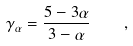<formula> <loc_0><loc_0><loc_500><loc_500>\gamma _ { \alpha } = \frac { 5 - 3 \alpha } { 3 - \alpha } \quad ,</formula> 